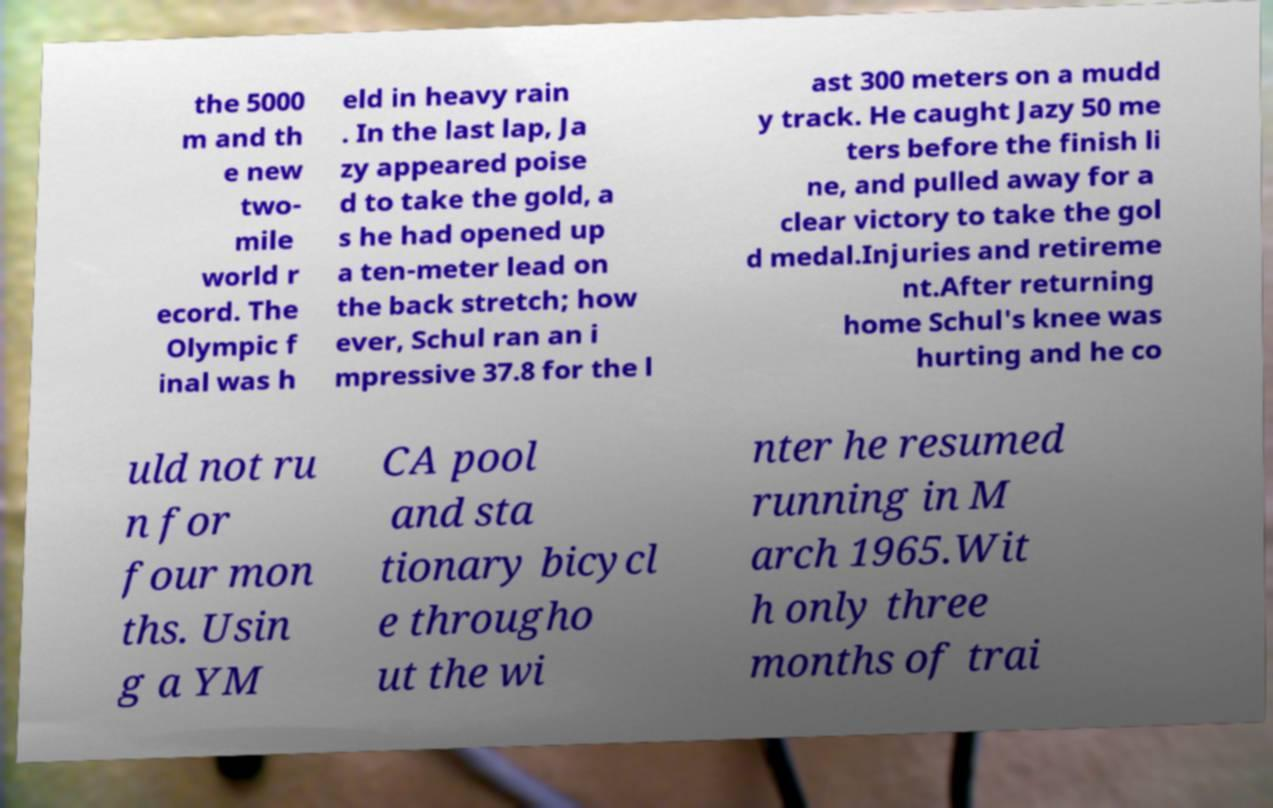There's text embedded in this image that I need extracted. Can you transcribe it verbatim? the 5000 m and th e new two- mile world r ecord. The Olympic f inal was h eld in heavy rain . In the last lap, Ja zy appeared poise d to take the gold, a s he had opened up a ten-meter lead on the back stretch; how ever, Schul ran an i mpressive 37.8 for the l ast 300 meters on a mudd y track. He caught Jazy 50 me ters before the finish li ne, and pulled away for a clear victory to take the gol d medal.Injuries and retireme nt.After returning home Schul's knee was hurting and he co uld not ru n for four mon ths. Usin g a YM CA pool and sta tionary bicycl e througho ut the wi nter he resumed running in M arch 1965.Wit h only three months of trai 